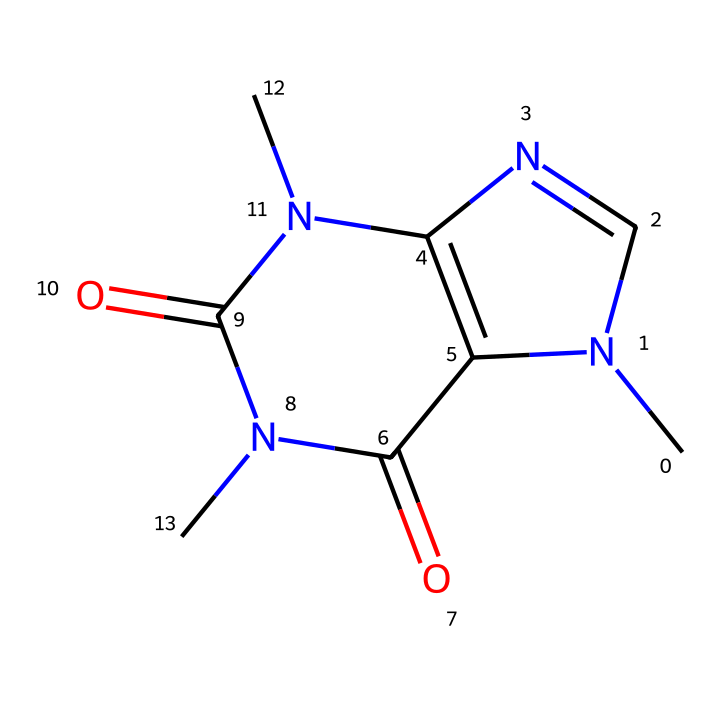What is the molecular formula of caffeine? By analyzing the SMILES representation, we can derive the molecular formula by counting the number of each type of atom present. In this compound, we observe 8 carbon atoms, 10 hydrogen atoms, 4 nitrogen atoms, and 2 oxygen atoms, leading to the molecular formula C8H10N4O2.
Answer: C8H10N4O2 How many nitrogen atoms are in caffeine? A quick count of the nitrogen (N) symbols in the chemical structure shows there are 4 nitrogen atoms present.
Answer: 4 What type of compound is caffeine? Caffeine is classified as an alkaloid, which is a type of medicinal compound characterized by the presence of nitrogen atoms and a complex structure. This classification is based on the molecular structure, which includes pyrimidine and imidazole rings.
Answer: alkaloid How many rings are present in the structure of caffeine? The chemical structure of caffeine features two fused ring systems (the bicyclic structure), which can be clearly identified in the SMILES representation. Counting these gives a total of two rings.
Answer: 2 What functional group is indicated by the presence of the C=O in the caffeine structure? The presence of the carbonyl group (C=O) in the structure indicates the existence of amide functional groups, contributing to the compound's properties as a medicinal compound.
Answer: amide What is the primary effect of caffeine on the human body? Caffeine primarily acts as a stimulant, enhancing alertness and reducing the perception of fatigue. This is due to its structure, which allows it to interact with adenosine receptors in the brain.
Answer: stimulant 